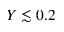<formula> <loc_0><loc_0><loc_500><loc_500>Y \lesssim 0 . 2</formula> 